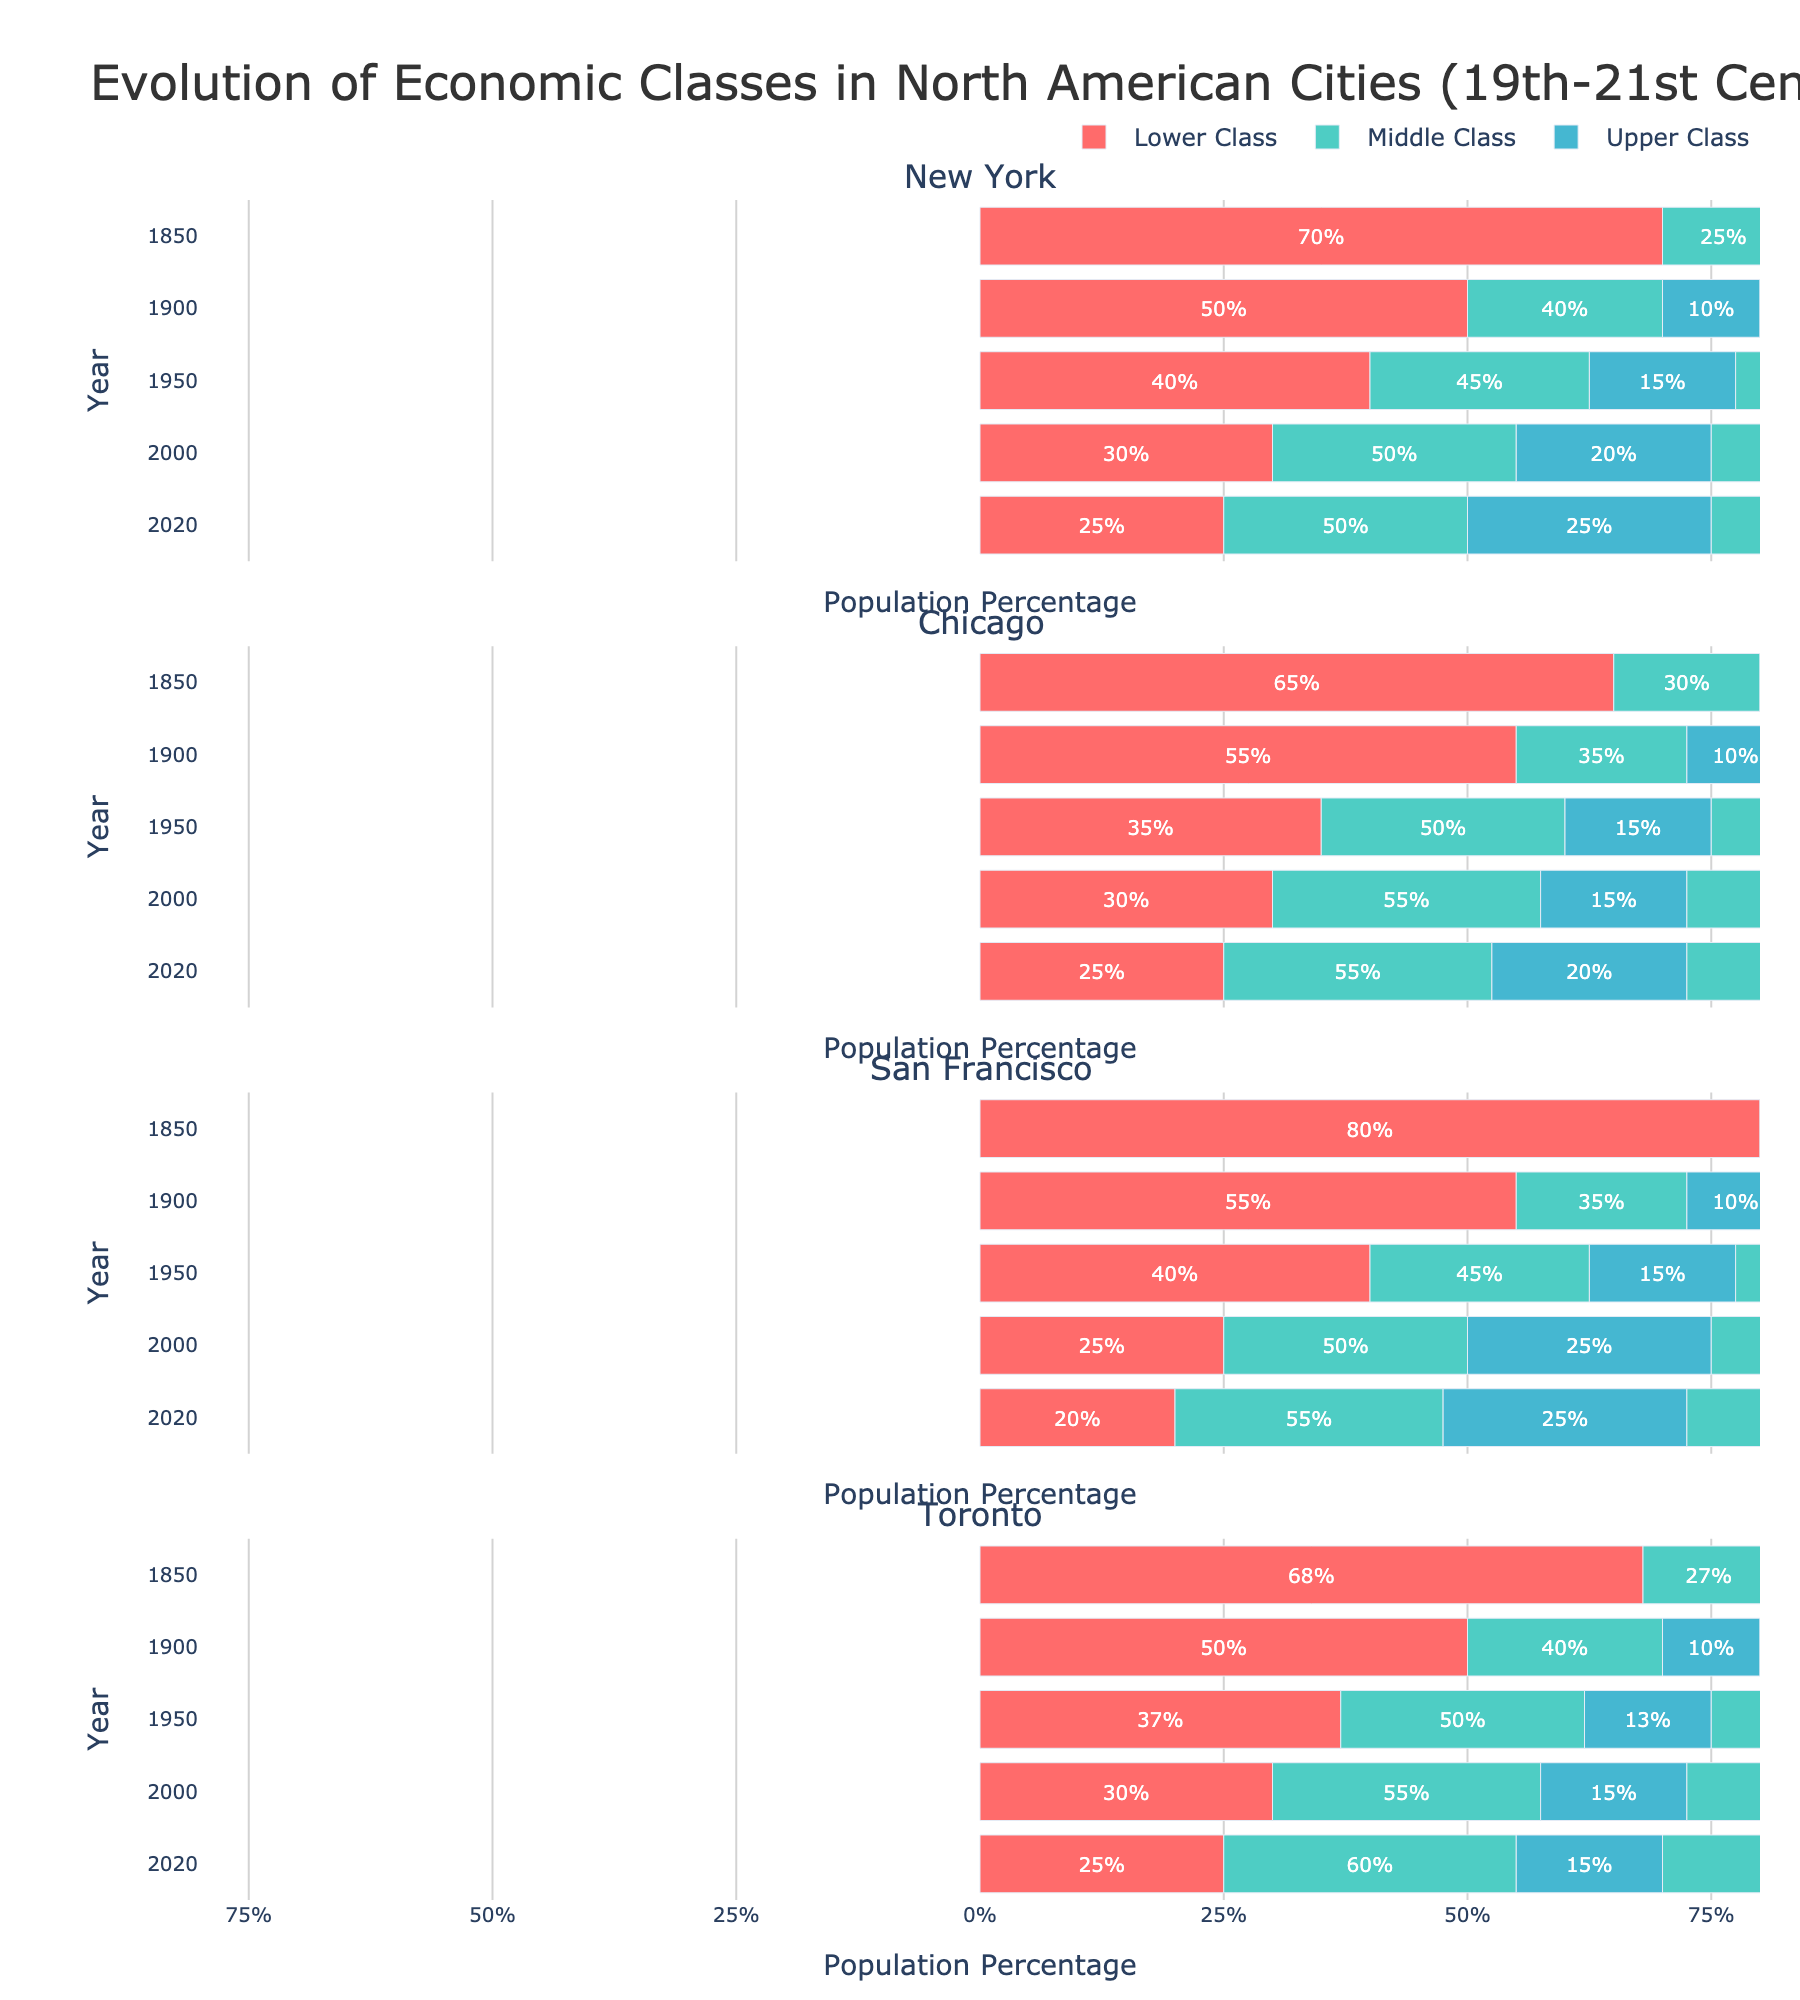What percentage of the population in New York was classified as lower class in 1850 compared to 2020? In the figure, the lower class segment is represented by the red bar. For New York, the lower class percentage in 1850 is 70%, and in 2020 it is 25%.
Answer: 70% in 1850, 25% in 2020 How has the representation of the middle class changed in Chicago from 1850 to 2020? To determine this, observe the green bar representing the middle class in Chicago for the years 1850 and 2020. In 1850, it was 30%, and in 2020, it was 55%.
Answer: Increased from 30% to 55% Which city had the highest percentage of the upper class in 2020? Look at the yellow sections of the bars for all cities in 2020. San Francisco has the highest upper class at 25%.
Answer: San Francisco In which year did Toronto have an equal distribution between the middle class and lower class? Find the green and red bars for Toronto and look for the year where they are approximately equal. In 1900, both middle and lower classes were close, with 40% middle and 50% lower class.
Answer: 1900 What is the total percentage of middle and upper class combined in New York in the year 2000? Sum the percentages of the green (middle class) and yellow (upper class) bars for New York in the year 2000. This is 50% (middle class) + 20% (upper class) = 70%.
Answer: 70% How does the lower class percentage in San Francisco in 1850 compare to that in 2020? Observe the red bar for lower class in San Francisco for both years. In 1850, it was 80%, and in 2020, it was 20%.
Answer: Decreased from 80% to 20% Which year shows the smallest difference in the percentage of the middle class between New York and Chicago? Calculate the difference in the green bar heights for New York and Chicago across the years. In 2020, New York has 50%, and Chicago has 55%, yielding a difference of 5%, which is the smallest among the years.
Answer: 2020 By how much has the upper class percentage increased in San Francisco from 1850 to 2020? Subtract the yellow bar percentage for San Francisco in 1850 from that in 2020 (25% - 5% = 20%).
Answer: 20% When did Toronto first see the middle class surpass the lower class? Examine the green and red bars for Toronto across the years. In 2000, the middle class at 55% surpassed the lower class at 30%.
Answer: 2000 Which city had the most stable middle class percentage from 1950 to 2020? Look at the green bars across 1950 to 2020 for all cities and determine which city has the least change. Chicago’s middle class remains relatively stable, ranging from 50% to 55%.
Answer: Chicago 